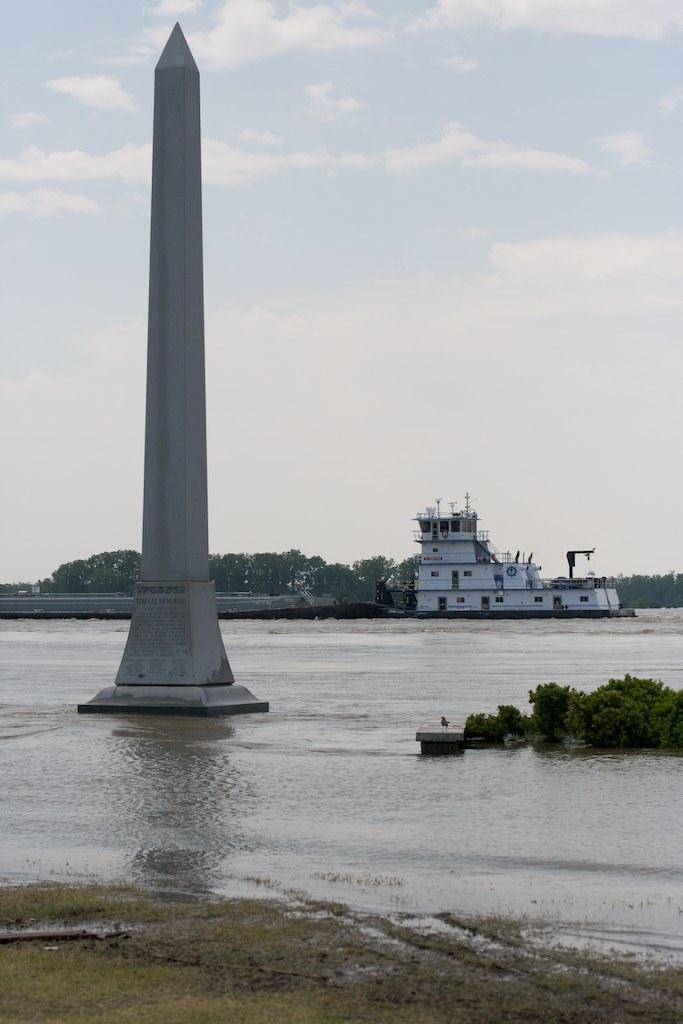What is the main structure in the image? There is a tower in the image. What can be seen on the water in the image? There is a ship on the water in the image. What type of vegetation is present in the image? There are trees in the image. Can you describe the objects in the image? There are some objects in the image, but their specific details are not mentioned in the facts. What is visible in the background of the image? The sky is visible in the background of the image. What type of collar can be seen on the ship in the image? There is no collar present on the ship in the image. What level of experience does the beginner have in the image? There is no indication of any person's experience level in the image. 